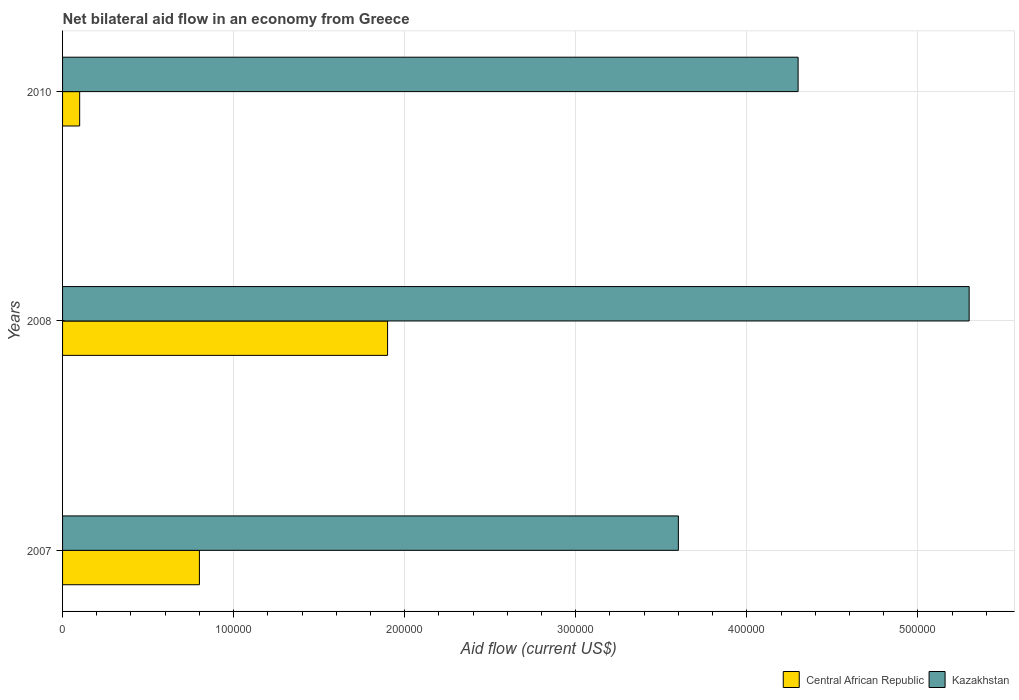Are the number of bars per tick equal to the number of legend labels?
Provide a short and direct response. Yes. How many bars are there on the 2nd tick from the bottom?
Your answer should be compact. 2. What is the label of the 2nd group of bars from the top?
Provide a succinct answer. 2008. What is the net bilateral aid flow in Kazakhstan in 2007?
Provide a short and direct response. 3.60e+05. Across all years, what is the maximum net bilateral aid flow in Central African Republic?
Your answer should be very brief. 1.90e+05. Across all years, what is the minimum net bilateral aid flow in Kazakhstan?
Offer a very short reply. 3.60e+05. What is the difference between the net bilateral aid flow in Kazakhstan in 2007 and that in 2010?
Provide a succinct answer. -7.00e+04. What is the difference between the net bilateral aid flow in Kazakhstan in 2010 and the net bilateral aid flow in Central African Republic in 2007?
Keep it short and to the point. 3.50e+05. In the year 2010, what is the difference between the net bilateral aid flow in Central African Republic and net bilateral aid flow in Kazakhstan?
Offer a terse response. -4.20e+05. What is the ratio of the net bilateral aid flow in Kazakhstan in 2007 to that in 2010?
Give a very brief answer. 0.84. What is the difference between the highest and the lowest net bilateral aid flow in Central African Republic?
Offer a very short reply. 1.80e+05. In how many years, is the net bilateral aid flow in Central African Republic greater than the average net bilateral aid flow in Central African Republic taken over all years?
Give a very brief answer. 1. Is the sum of the net bilateral aid flow in Central African Republic in 2007 and 2010 greater than the maximum net bilateral aid flow in Kazakhstan across all years?
Provide a short and direct response. No. What does the 2nd bar from the top in 2007 represents?
Ensure brevity in your answer.  Central African Republic. What does the 2nd bar from the bottom in 2010 represents?
Ensure brevity in your answer.  Kazakhstan. How many years are there in the graph?
Provide a short and direct response. 3. What is the difference between two consecutive major ticks on the X-axis?
Offer a terse response. 1.00e+05. Where does the legend appear in the graph?
Ensure brevity in your answer.  Bottom right. What is the title of the graph?
Ensure brevity in your answer.  Net bilateral aid flow in an economy from Greece. What is the label or title of the Y-axis?
Your response must be concise. Years. What is the Aid flow (current US$) of Central African Republic in 2007?
Your response must be concise. 8.00e+04. What is the Aid flow (current US$) of Kazakhstan in 2008?
Offer a very short reply. 5.30e+05. What is the Aid flow (current US$) in Central African Republic in 2010?
Offer a terse response. 10000. Across all years, what is the maximum Aid flow (current US$) in Central African Republic?
Your response must be concise. 1.90e+05. Across all years, what is the maximum Aid flow (current US$) of Kazakhstan?
Your response must be concise. 5.30e+05. Across all years, what is the minimum Aid flow (current US$) in Central African Republic?
Make the answer very short. 10000. What is the total Aid flow (current US$) in Kazakhstan in the graph?
Provide a succinct answer. 1.32e+06. What is the difference between the Aid flow (current US$) of Central African Republic in 2007 and that in 2008?
Offer a terse response. -1.10e+05. What is the difference between the Aid flow (current US$) of Central African Republic in 2007 and that in 2010?
Make the answer very short. 7.00e+04. What is the difference between the Aid flow (current US$) in Central African Republic in 2008 and that in 2010?
Your answer should be very brief. 1.80e+05. What is the difference between the Aid flow (current US$) in Kazakhstan in 2008 and that in 2010?
Your response must be concise. 1.00e+05. What is the difference between the Aid flow (current US$) in Central African Republic in 2007 and the Aid flow (current US$) in Kazakhstan in 2008?
Your answer should be compact. -4.50e+05. What is the difference between the Aid flow (current US$) of Central African Republic in 2007 and the Aid flow (current US$) of Kazakhstan in 2010?
Offer a terse response. -3.50e+05. What is the average Aid flow (current US$) of Central African Republic per year?
Your response must be concise. 9.33e+04. What is the average Aid flow (current US$) in Kazakhstan per year?
Your response must be concise. 4.40e+05. In the year 2007, what is the difference between the Aid flow (current US$) of Central African Republic and Aid flow (current US$) of Kazakhstan?
Offer a very short reply. -2.80e+05. In the year 2008, what is the difference between the Aid flow (current US$) in Central African Republic and Aid flow (current US$) in Kazakhstan?
Provide a short and direct response. -3.40e+05. In the year 2010, what is the difference between the Aid flow (current US$) of Central African Republic and Aid flow (current US$) of Kazakhstan?
Provide a short and direct response. -4.20e+05. What is the ratio of the Aid flow (current US$) in Central African Republic in 2007 to that in 2008?
Your answer should be very brief. 0.42. What is the ratio of the Aid flow (current US$) in Kazakhstan in 2007 to that in 2008?
Provide a short and direct response. 0.68. What is the ratio of the Aid flow (current US$) of Kazakhstan in 2007 to that in 2010?
Offer a very short reply. 0.84. What is the ratio of the Aid flow (current US$) of Kazakhstan in 2008 to that in 2010?
Ensure brevity in your answer.  1.23. What is the difference between the highest and the second highest Aid flow (current US$) of Central African Republic?
Your answer should be compact. 1.10e+05. 